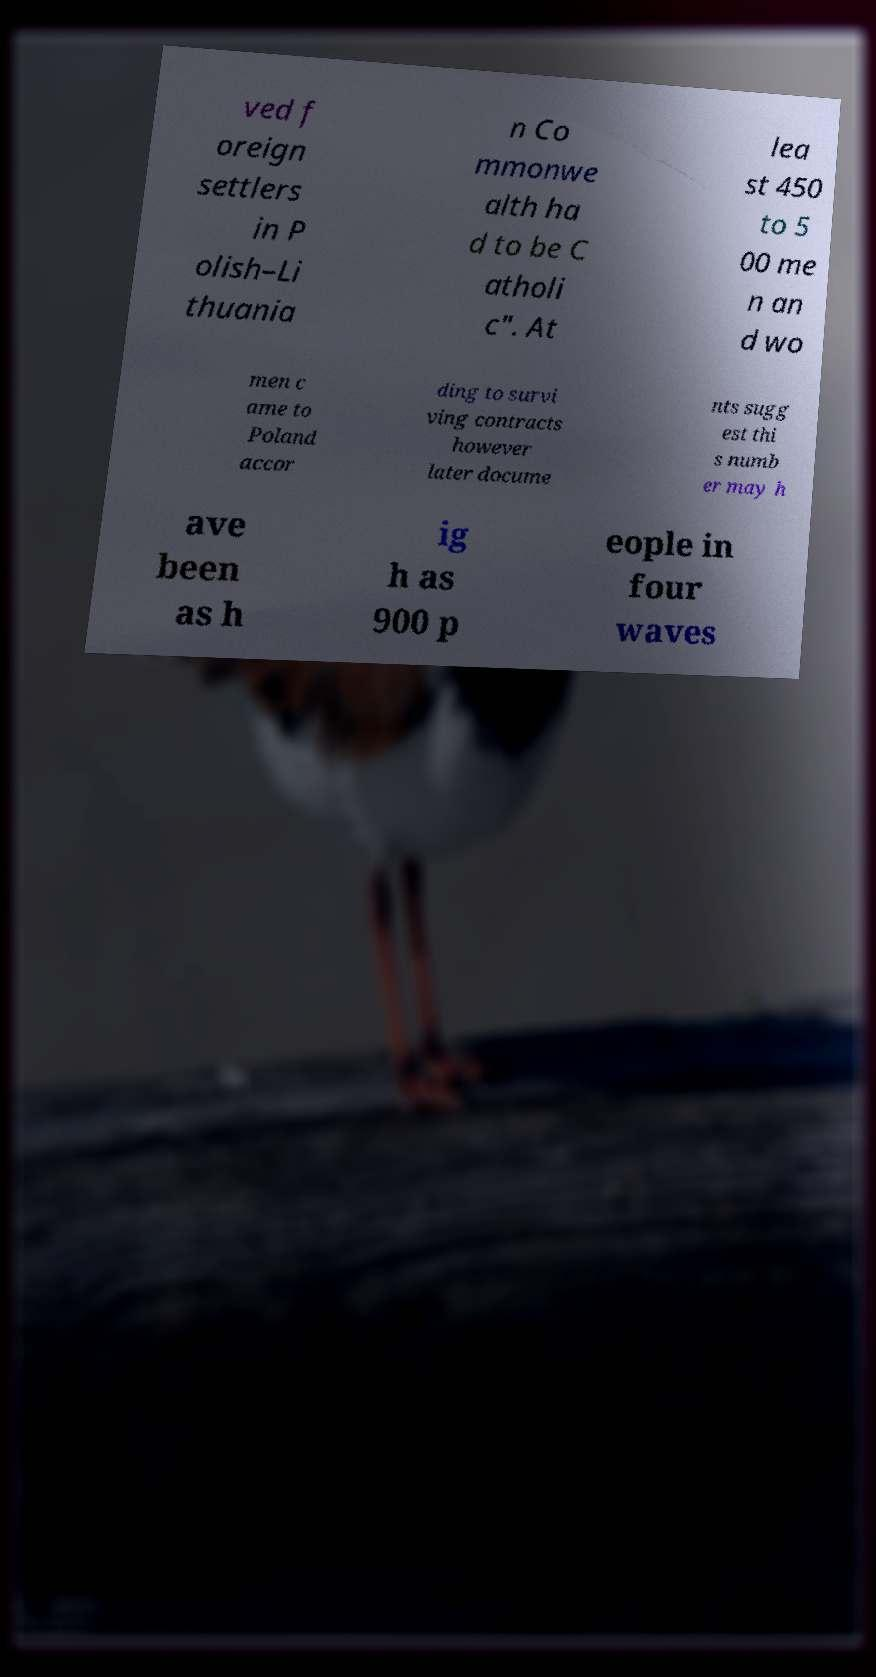Can you accurately transcribe the text from the provided image for me? ved f oreign settlers in P olish–Li thuania n Co mmonwe alth ha d to be C atholi c". At lea st 450 to 5 00 me n an d wo men c ame to Poland accor ding to survi ving contracts however later docume nts sugg est thi s numb er may h ave been as h ig h as 900 p eople in four waves 